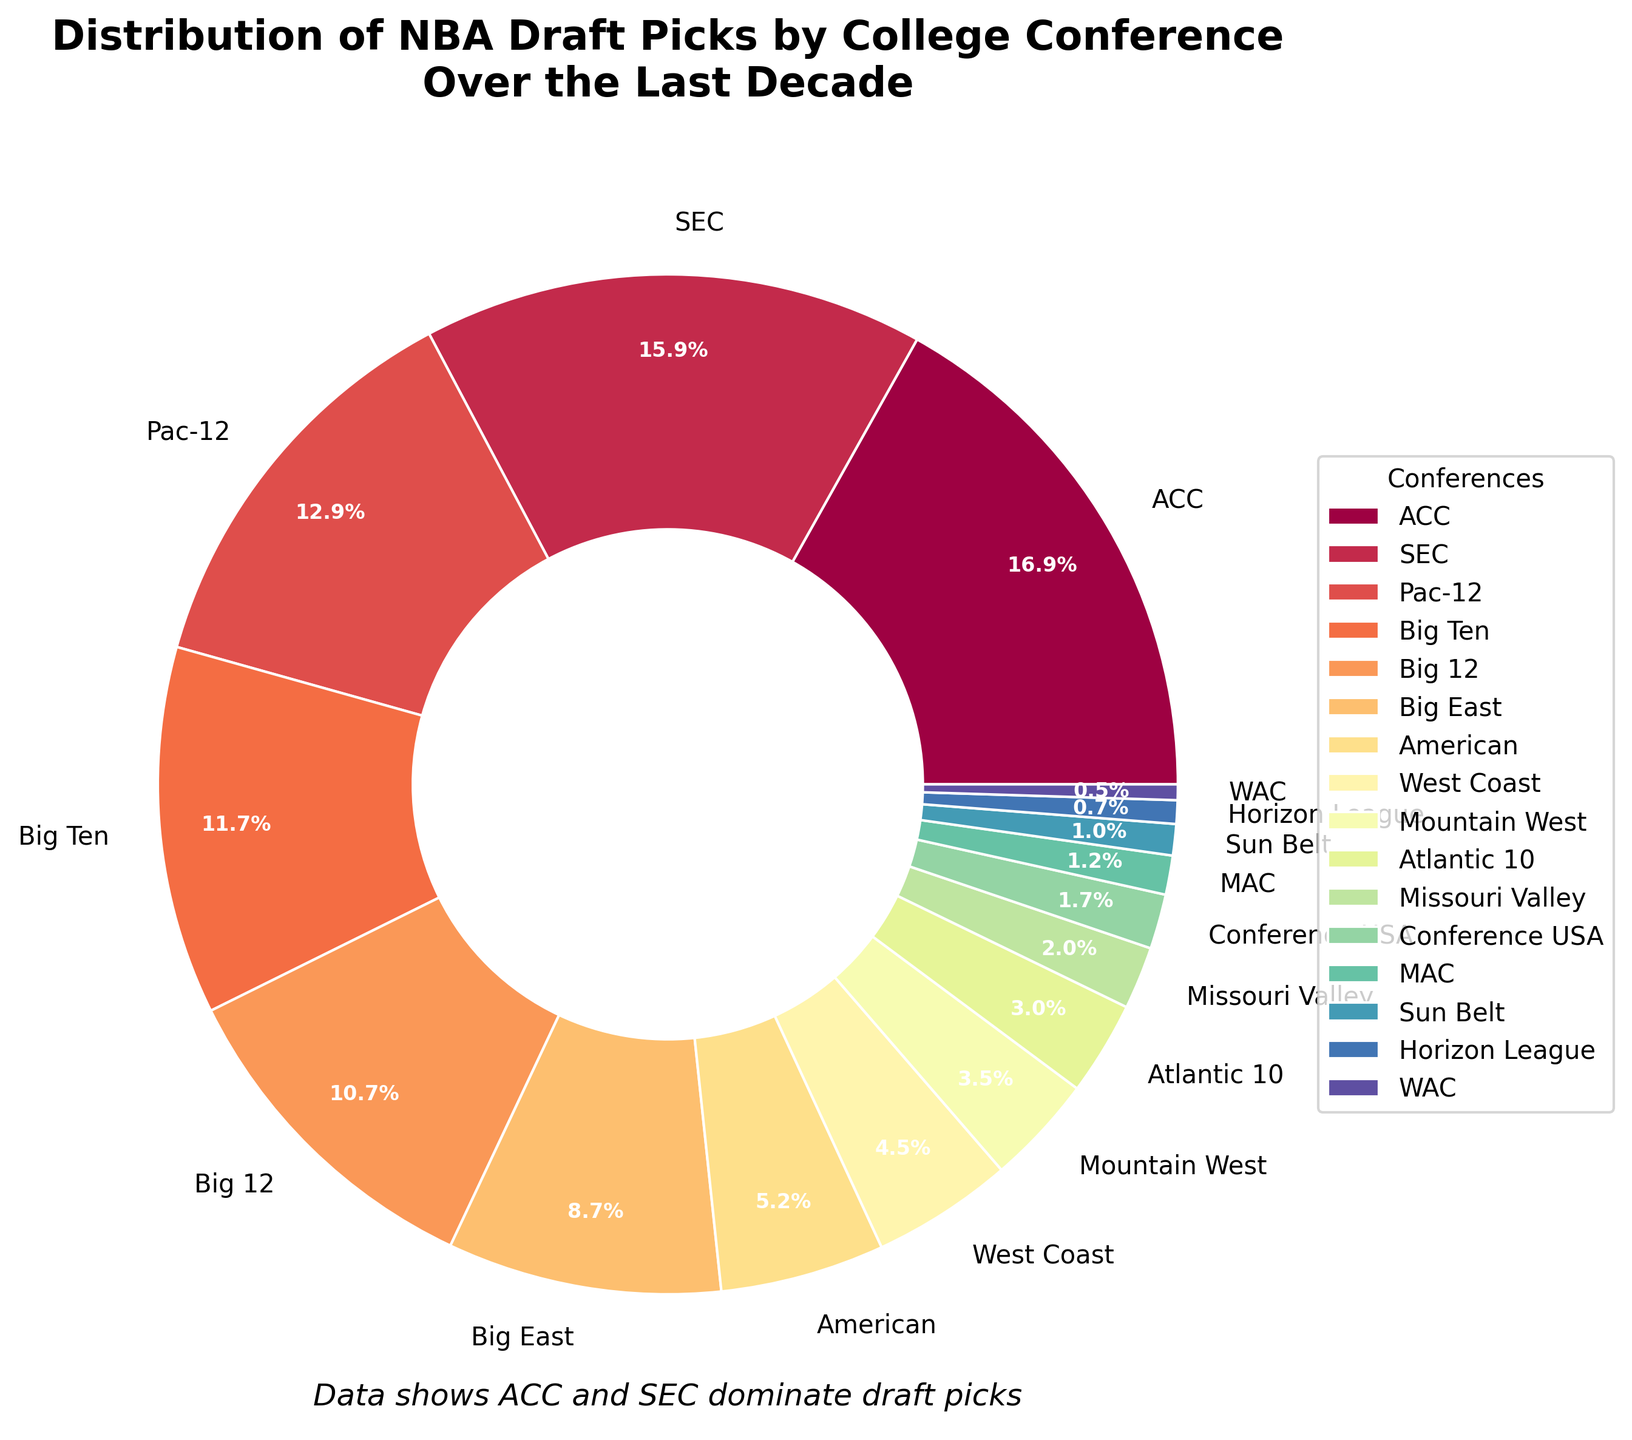What percentage of NBA draft picks came from the ACC conference over the last decade? Look at the ACC section of the pie chart which shows the percentage next to the label "ACC".
Answer: 20.8% Which conference has the fewest NBA draft picks over the last decade? Identify the smallest wedge in the pie chart. This represents the WAC conference.
Answer: WAC What is the combined percentage of draft picks from the ACC and SEC conferences? Locate the percentages for ACC and SEC on the pie chart (20.8% and 19.6% respectively), then add them together.
Answer: 40.4% Which conference had more draft picks over the last decade, the Big 12 or the Big East? Compare the sizes and percentages of the wedges for the Big 12 and Big East in the pie chart. The Big 12 has a larger wedge with a higher percentage.
Answer: Big 12 Are there more NBA draft picks from the Pac-12 or from the Big Ten conference? Compare the wedges for the Pac-12 and the Big Ten, noting the percentages displayed. The Pac-12 wedge is larger.
Answer: Pac-12 What visual attribute differentiates the SEC from the Big Ten wedge in the pie chart? Compare the wedges for SEC and Big Ten and note the color of each wedge.
Answer: Different colors Calculate the total number of draft picks from non-Power 5 conferences (American, West Coast, Mountain West, Atlantic 10, Missouri Valley, Conference USA, MAC, Sun Belt, Horizon League, WAC). Add up the draft pick numbers from all non-Power 5 conferences: 21 + 18 + 14 + 12 + 8 + 7 + 5 + 4 + 3 + 2 = 94.
Answer: 94 Which non-Power 5 conference has the highest number of draft picks? Identify the largest wedge among the non-Power 5 conferences (American, West Coast, etc.), which is the American Athletic Conference.
Answer: American If you combined the draft picks from the Pac-12 and Big 12, would their total be higher than that of the SEC? Calculate the combined total for Pac-12 and Big 12 (52 + 43 = 95) and compare it with the SEC total (64). 95 is greater than 64.
Answer: Yes How many conferences contributed exactly 2% or less of the total draft picks? Look at the pie chart and count the wedges that represent 2% or less, which are Conference USA, MAC, Sun Belt, Horizon League, and WAC.
Answer: 5 What visual element highlights that the ACC and SEC dominate the draft picks visually? Look at the text below the pie chart indicating "Data shows ACC and SEC dominate draft picks", and notice the larger wedges corresponding to these conferences in the chart.
Answer: Larger wedges and text note 